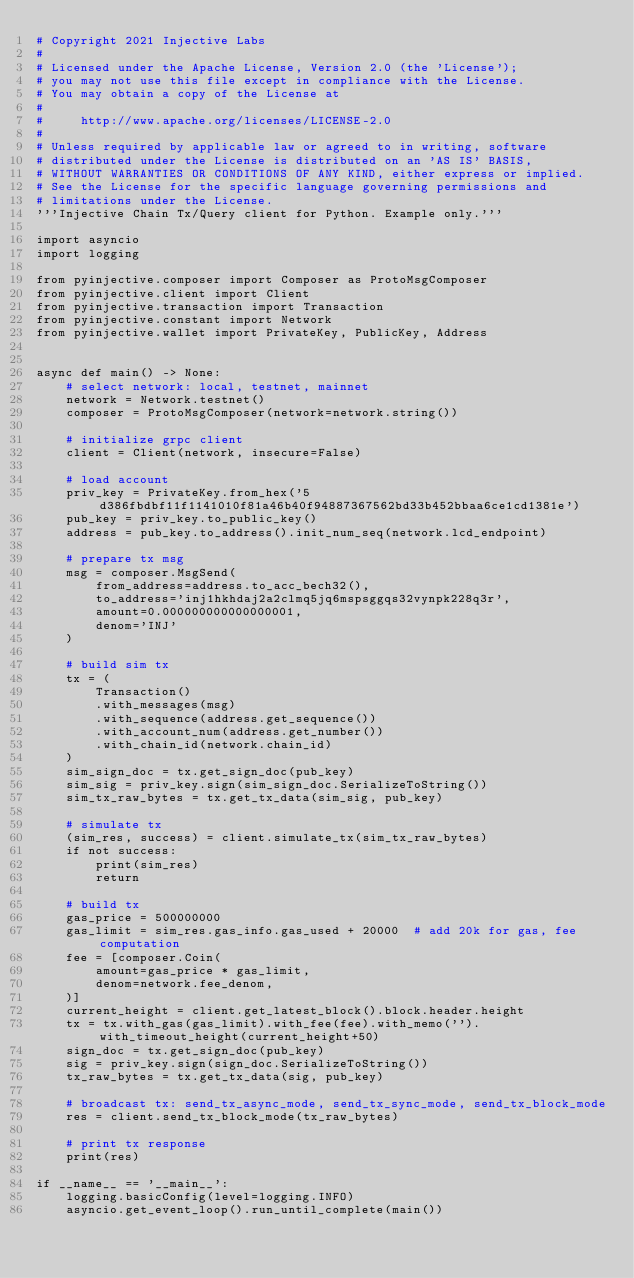Convert code to text. <code><loc_0><loc_0><loc_500><loc_500><_Python_># Copyright 2021 Injective Labs
#
# Licensed under the Apache License, Version 2.0 (the 'License');
# you may not use this file except in compliance with the License.
# You may obtain a copy of the License at
#
#     http://www.apache.org/licenses/LICENSE-2.0
#
# Unless required by applicable law or agreed to in writing, software
# distributed under the License is distributed on an 'AS IS' BASIS,
# WITHOUT WARRANTIES OR CONDITIONS OF ANY KIND, either express or implied.
# See the License for the specific language governing permissions and
# limitations under the License.
'''Injective Chain Tx/Query client for Python. Example only.'''

import asyncio
import logging

from pyinjective.composer import Composer as ProtoMsgComposer
from pyinjective.client import Client
from pyinjective.transaction import Transaction
from pyinjective.constant import Network
from pyinjective.wallet import PrivateKey, PublicKey, Address


async def main() -> None:
    # select network: local, testnet, mainnet
    network = Network.testnet()
    composer = ProtoMsgComposer(network=network.string())

    # initialize grpc client
    client = Client(network, insecure=False)

    # load account
    priv_key = PrivateKey.from_hex('5d386fbdbf11f1141010f81a46b40f94887367562bd33b452bbaa6ce1cd1381e')
    pub_key = priv_key.to_public_key()
    address = pub_key.to_address().init_num_seq(network.lcd_endpoint)

    # prepare tx msg
    msg = composer.MsgSend(
        from_address=address.to_acc_bech32(),
        to_address='inj1hkhdaj2a2clmq5jq6mspsggqs32vynpk228q3r',
        amount=0.000000000000000001,
        denom='INJ'
    )

    # build sim tx
    tx = (
        Transaction()
        .with_messages(msg)
        .with_sequence(address.get_sequence())
        .with_account_num(address.get_number())
        .with_chain_id(network.chain_id)
    )
    sim_sign_doc = tx.get_sign_doc(pub_key)
    sim_sig = priv_key.sign(sim_sign_doc.SerializeToString())
    sim_tx_raw_bytes = tx.get_tx_data(sim_sig, pub_key)

    # simulate tx
    (sim_res, success) = client.simulate_tx(sim_tx_raw_bytes)
    if not success:
        print(sim_res)
        return

    # build tx
    gas_price = 500000000
    gas_limit = sim_res.gas_info.gas_used + 20000  # add 20k for gas, fee computation
    fee = [composer.Coin(
        amount=gas_price * gas_limit,
        denom=network.fee_denom,
    )]
    current_height = client.get_latest_block().block.header.height
    tx = tx.with_gas(gas_limit).with_fee(fee).with_memo('').with_timeout_height(current_height+50)
    sign_doc = tx.get_sign_doc(pub_key)
    sig = priv_key.sign(sign_doc.SerializeToString())
    tx_raw_bytes = tx.get_tx_data(sig, pub_key)

    # broadcast tx: send_tx_async_mode, send_tx_sync_mode, send_tx_block_mode
    res = client.send_tx_block_mode(tx_raw_bytes)

    # print tx response
    print(res)

if __name__ == '__main__':
    logging.basicConfig(level=logging.INFO)
    asyncio.get_event_loop().run_until_complete(main())
</code> 